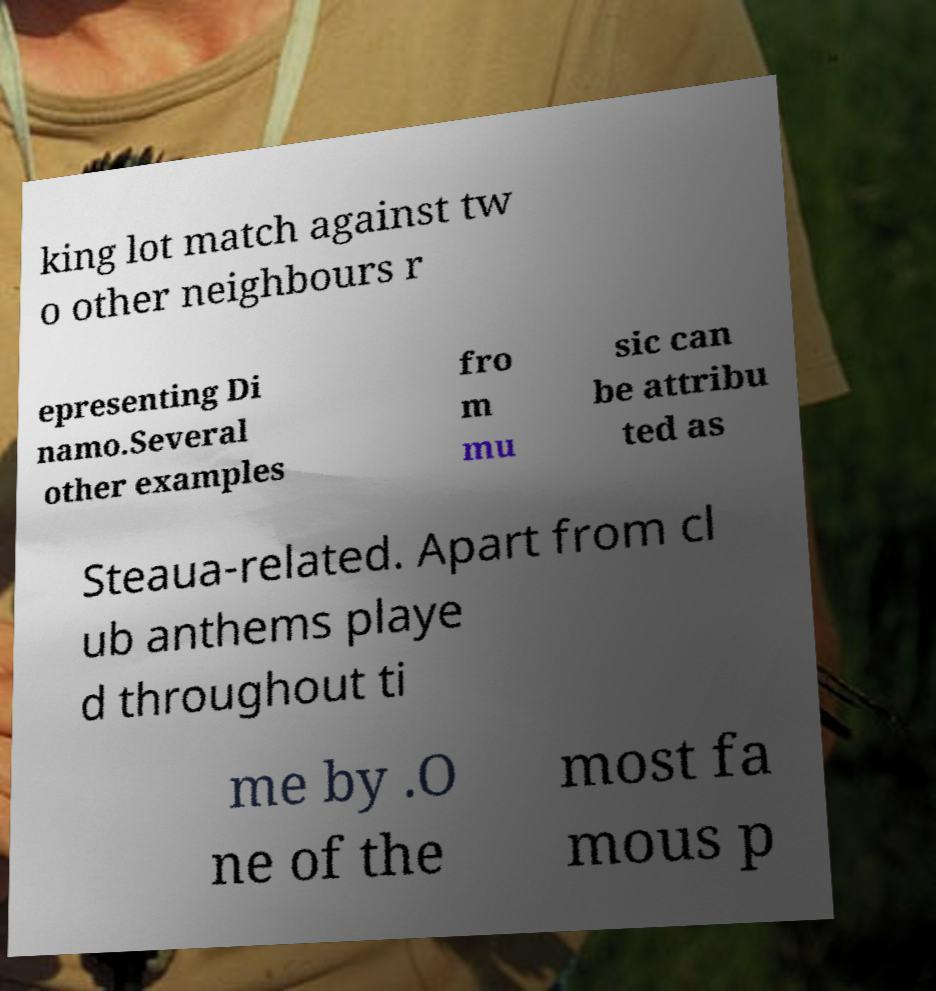Please identify and transcribe the text found in this image. king lot match against tw o other neighbours r epresenting Di namo.Several other examples fro m mu sic can be attribu ted as Steaua-related. Apart from cl ub anthems playe d throughout ti me by .O ne of the most fa mous p 